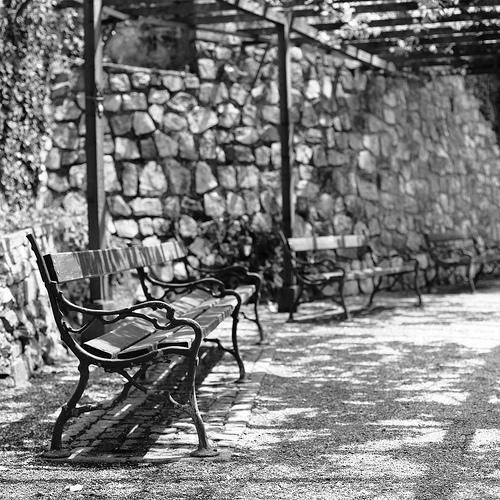How many benches do you see?
Give a very brief answer. 3. 